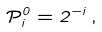Convert formula to latex. <formula><loc_0><loc_0><loc_500><loc_500>\mathcal { P } _ { i } ^ { 0 } = 2 ^ { - i } \, ,</formula> 